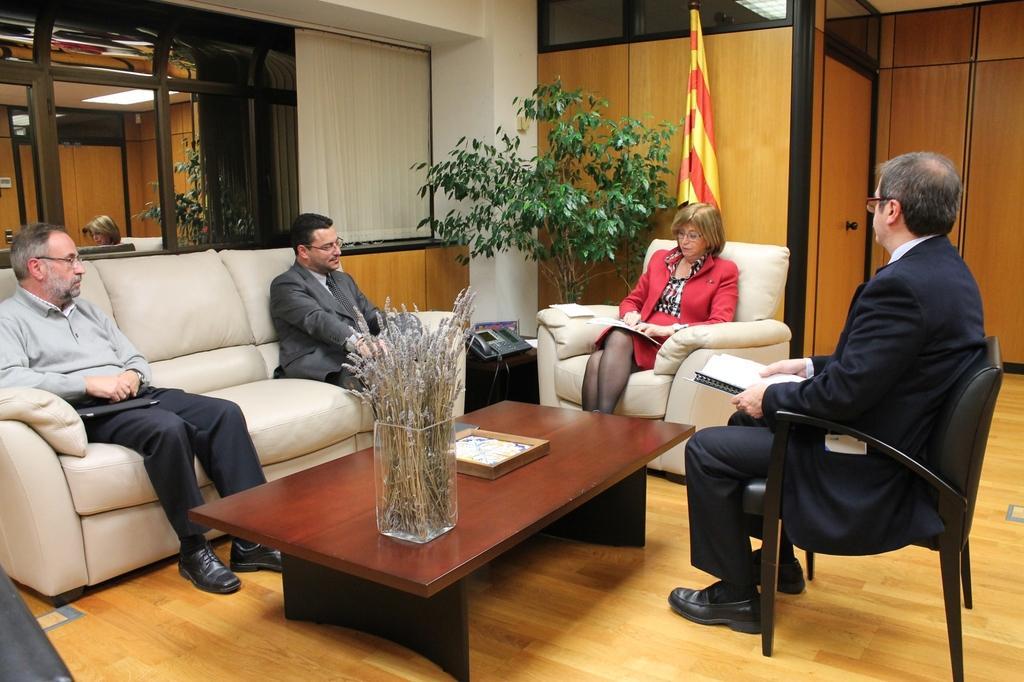Please provide a concise description of this image. In the middle there is a woman she wear red dress , her hair is short. On the right there is a man he wear suit ,trouser and shoes ,he is sitting on the chair. In the middle there is a table on that table there is a flower vase. On the left there is a sofa on that sofa there are two man. In the background there is a plant ,flag ,window ,curtain and door. 